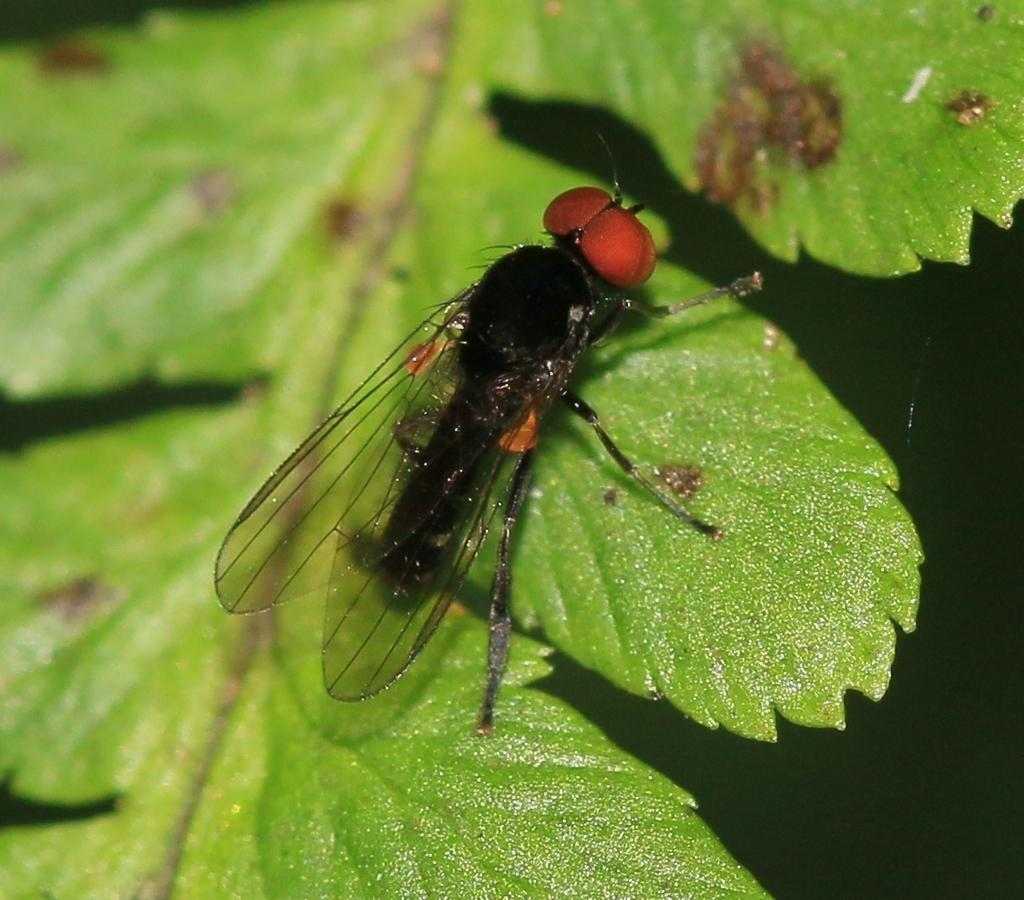What is present on the leaf in the image? There is a fly on a leaf in the image. What type of battle is taking place on the leaf in the image? There is no battle present on the leaf in the image; it features a fly on a leaf. What type of bun is visible on the leaf in the image? There is no bun present on the leaf in the image; it features a fly on a leaf. 